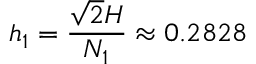Convert formula to latex. <formula><loc_0><loc_0><loc_500><loc_500>h _ { 1 } = \frac { \sqrt { 2 } H } { N _ { 1 } } \approx 0 . 2 8 2 8</formula> 